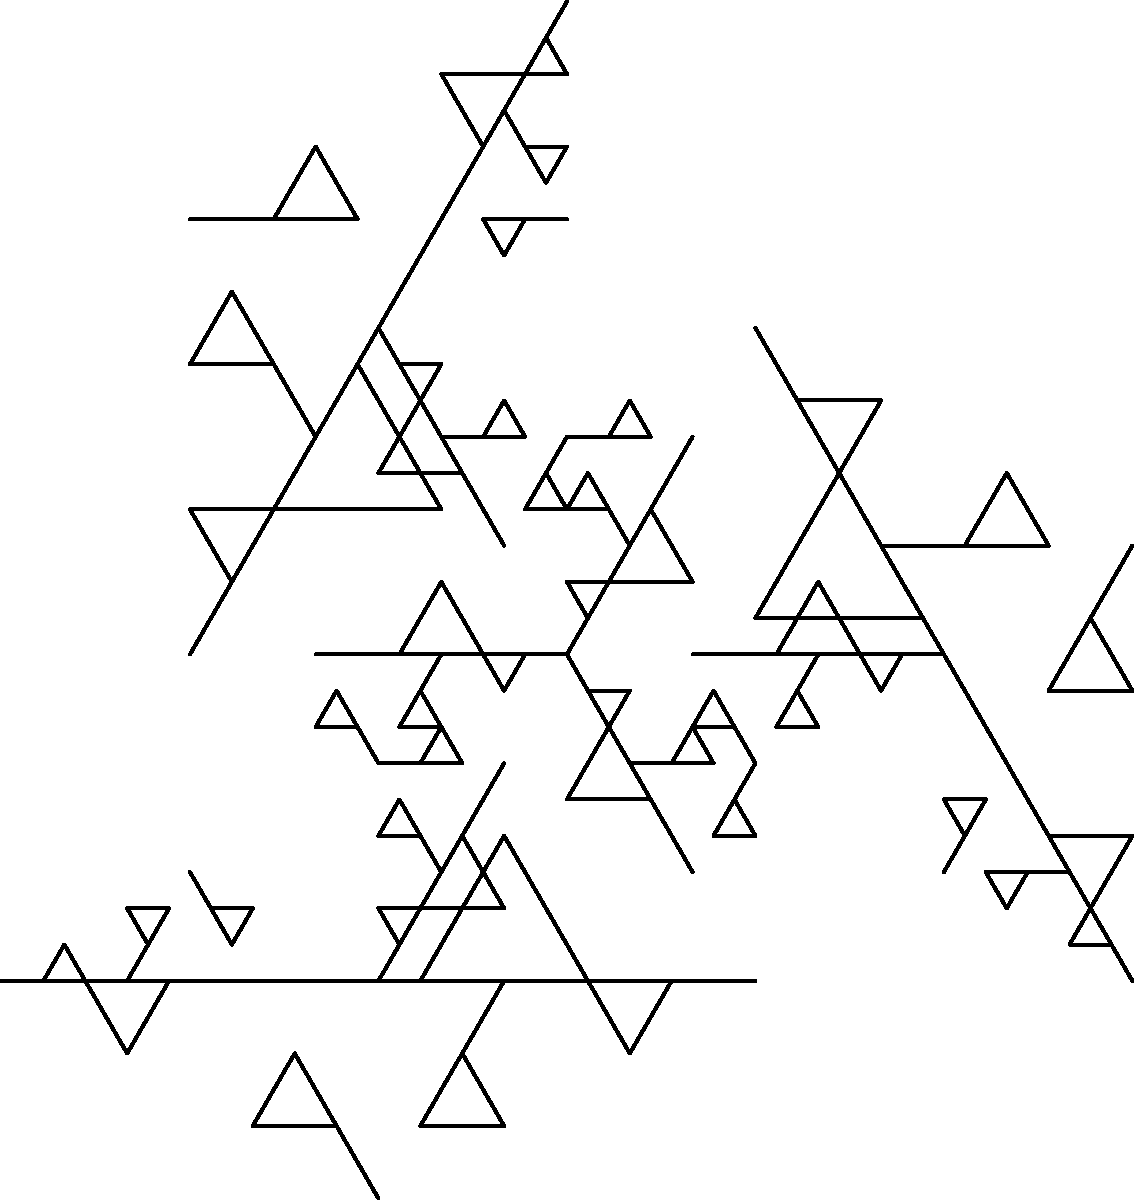Consider a Koch snowflake-like shape formed by an iterative process, as shown in the figure. The initial shape is an equilateral triangle with side length 1. In each iteration, the middle third of each line segment is replaced by two line segments forming an equilateral triangle. After 3 iterations, what is the perimeter of the resulting shape? Express your answer in terms of $(\frac{4}{3})^n$, where $n$ is the number of iterations. To solve this problem, let's follow these steps:

1) First, we need to understand how the perimeter changes in each iteration:
   - Initial perimeter (0th iteration): 3 (three sides of length 1)
   - After 1st iteration: Each side is replaced by 4 segments of length 1/3
   - So, the length multiplies by 4/3 in each iteration

2) We can express this mathematically:
   $P_n = P_0 \cdot (\frac{4}{3})^n$
   where $P_n$ is the perimeter after $n$ iterations, and $P_0$ is the initial perimeter

3) In this case:
   $P_0 = 3$ (initial perimeter)
   $n = 3$ (number of iterations)

4) Plugging these values into our formula:
   $P_3 = 3 \cdot (\frac{4}{3})^3$

5) This simplifies to:
   $P_3 = 3 \cdot (\frac{4}{3})^3 = 3 \cdot (\frac{4}{3})^3$

Therefore, after 3 iterations, the perimeter is $3 \cdot (\frac{4}{3})^3$.
Answer: $3 \cdot (\frac{4}{3})^3$ 